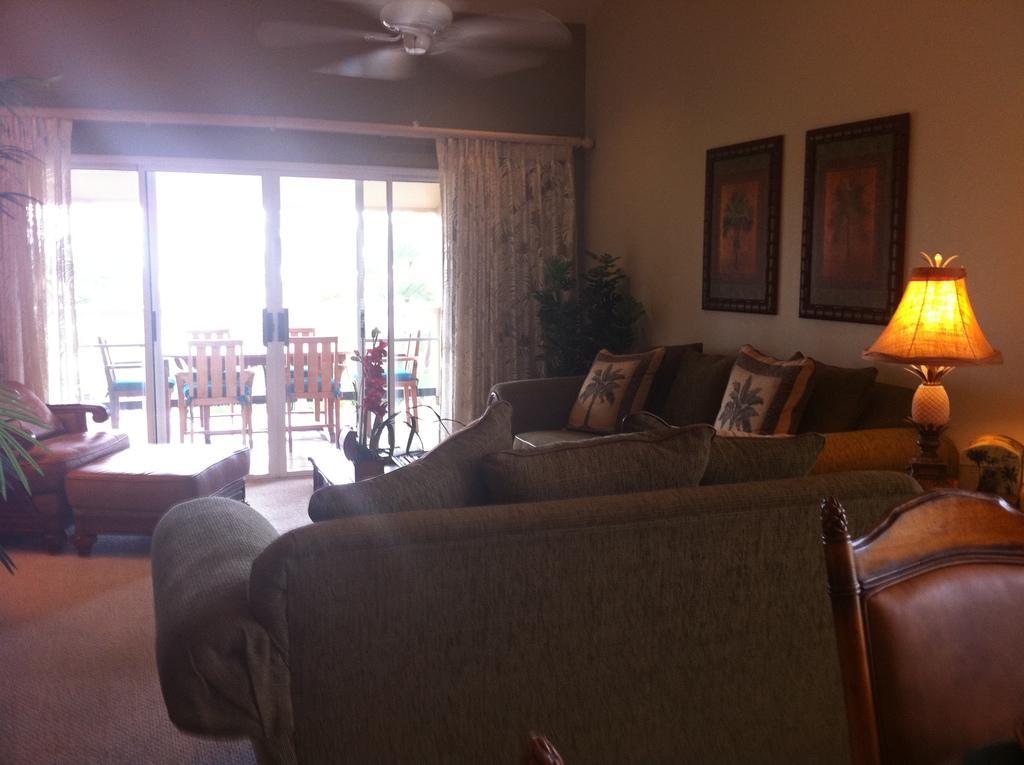Describe this image in one or two sentences. This is the image of the living room where there is a fan attached to the ceiling and a there is a carpet and in that carpet there are couch , 3 pillows , another couch , 2 pillows , a lamp in the table , a photo frame attached to the wall , a plant inside the living room , curtain and at the back ground there are dining table and door. 